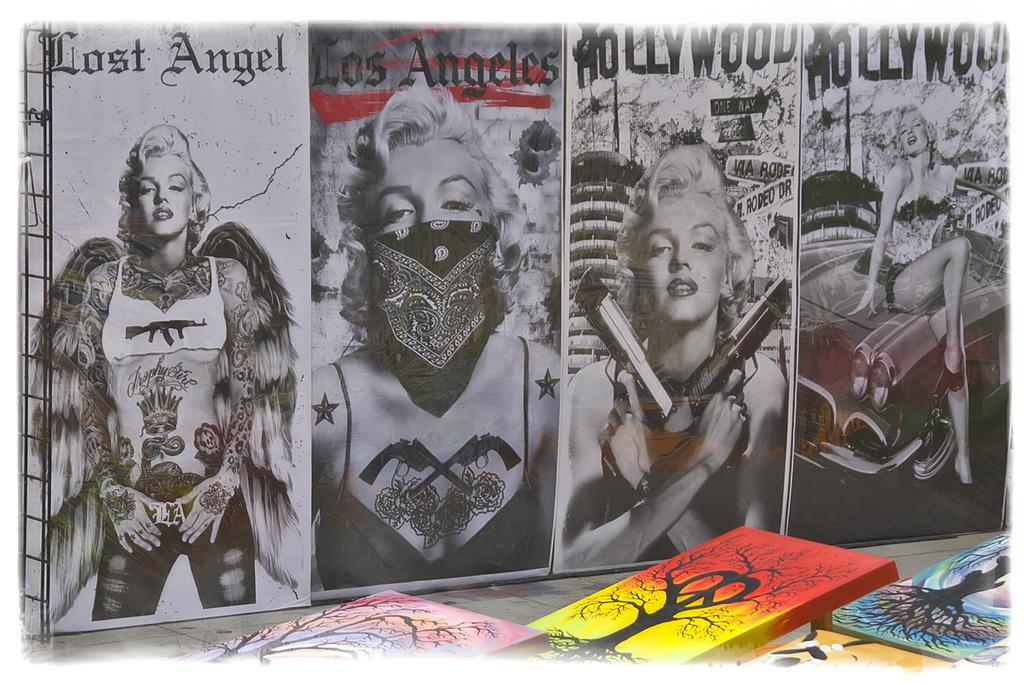What is located in the center of the image? There are boxes in the center of the image. What can be seen in the background of the image? There is a poster in the background of the image. What is depicted on the poster? There are people visible on the poster. What is written or displayed on the poster? There is something written on the poster. How much sand is visible on the poster in the image? There is no sand visible on the poster in the image. What organization is represented by the people on the poster? The provided facts do not mention any organization, so we cannot determine which organization the people on the poster represent. 